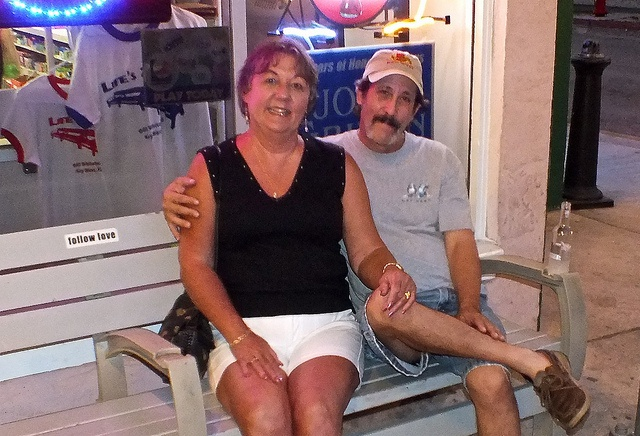Describe the objects in this image and their specific colors. I can see people in blue, black, brown, and salmon tones, bench in blue, darkgray, and gray tones, people in blue, darkgray, brown, maroon, and gray tones, handbag in blue, black, maroon, and gray tones, and bottle in blue, gray, darkgray, and brown tones in this image. 